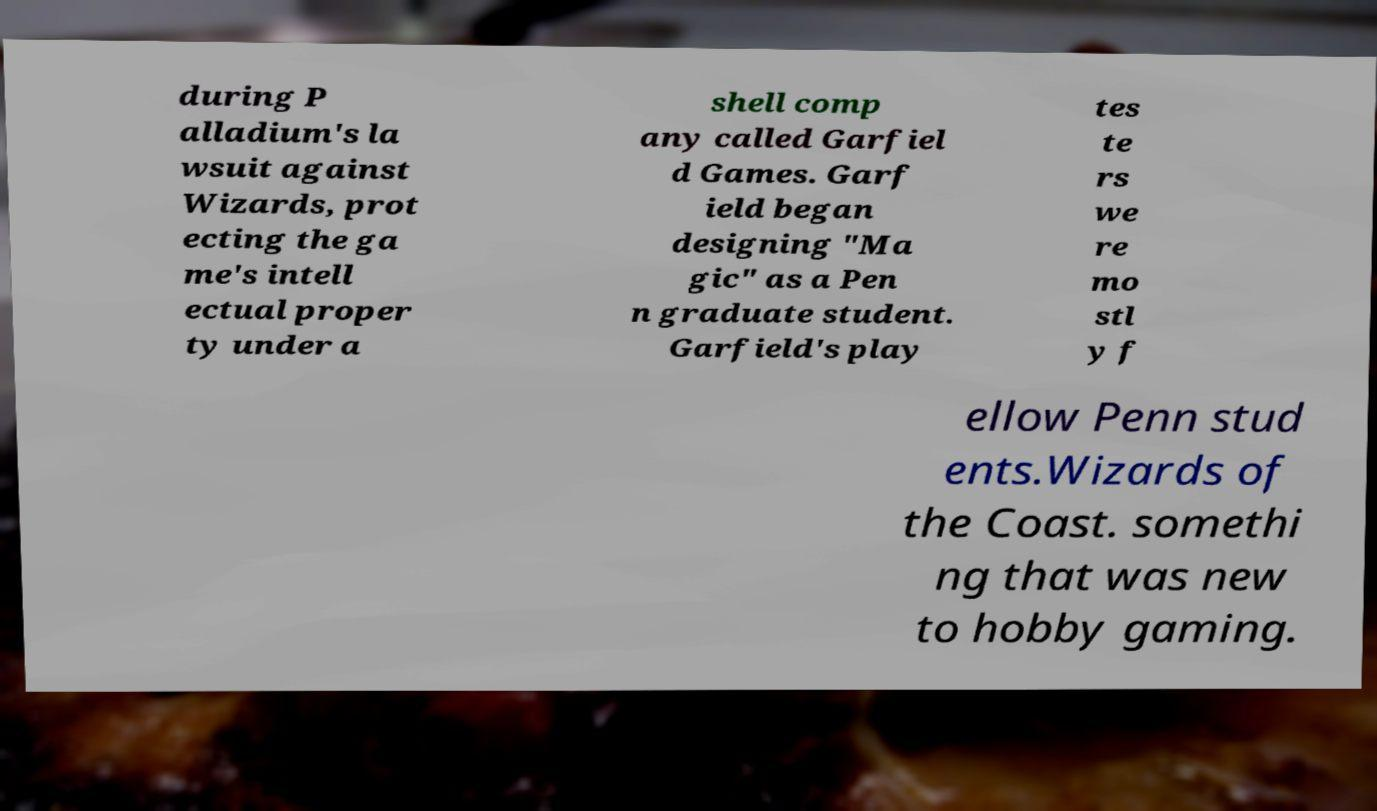For documentation purposes, I need the text within this image transcribed. Could you provide that? during P alladium's la wsuit against Wizards, prot ecting the ga me's intell ectual proper ty under a shell comp any called Garfiel d Games. Garf ield began designing "Ma gic" as a Pen n graduate student. Garfield's play tes te rs we re mo stl y f ellow Penn stud ents.Wizards of the Coast. somethi ng that was new to hobby gaming. 